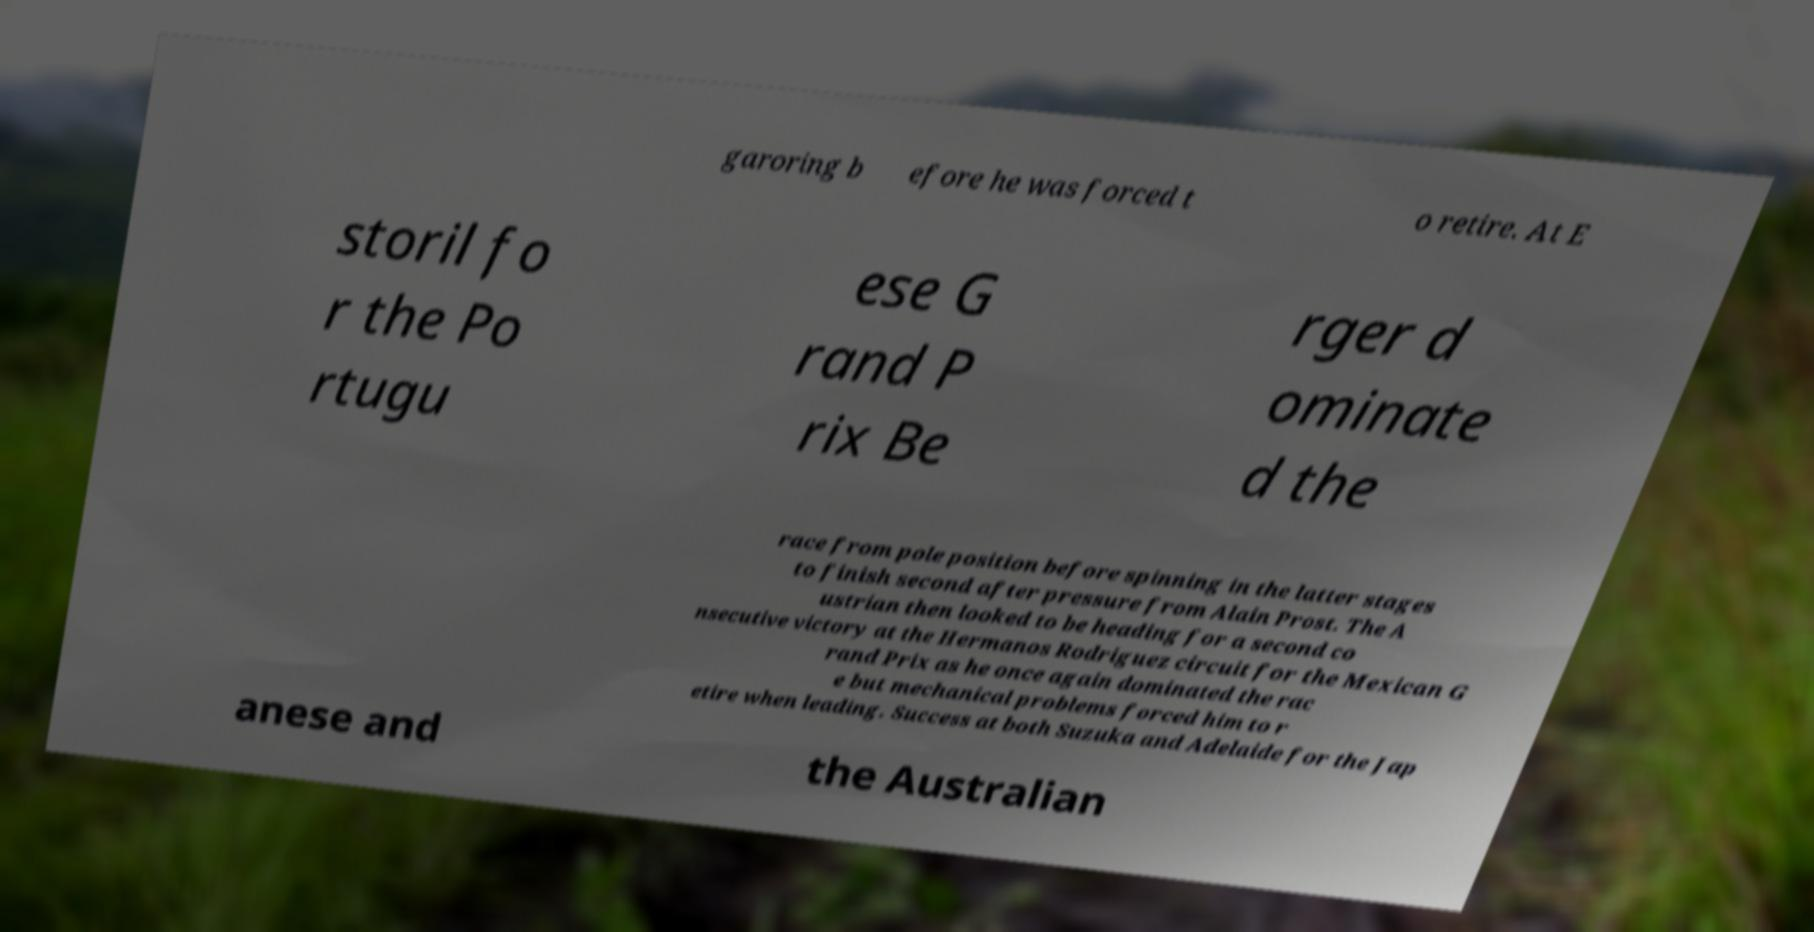What messages or text are displayed in this image? I need them in a readable, typed format. garoring b efore he was forced t o retire. At E storil fo r the Po rtugu ese G rand P rix Be rger d ominate d the race from pole position before spinning in the latter stages to finish second after pressure from Alain Prost. The A ustrian then looked to be heading for a second co nsecutive victory at the Hermanos Rodriguez circuit for the Mexican G rand Prix as he once again dominated the rac e but mechanical problems forced him to r etire when leading. Success at both Suzuka and Adelaide for the Jap anese and the Australian 